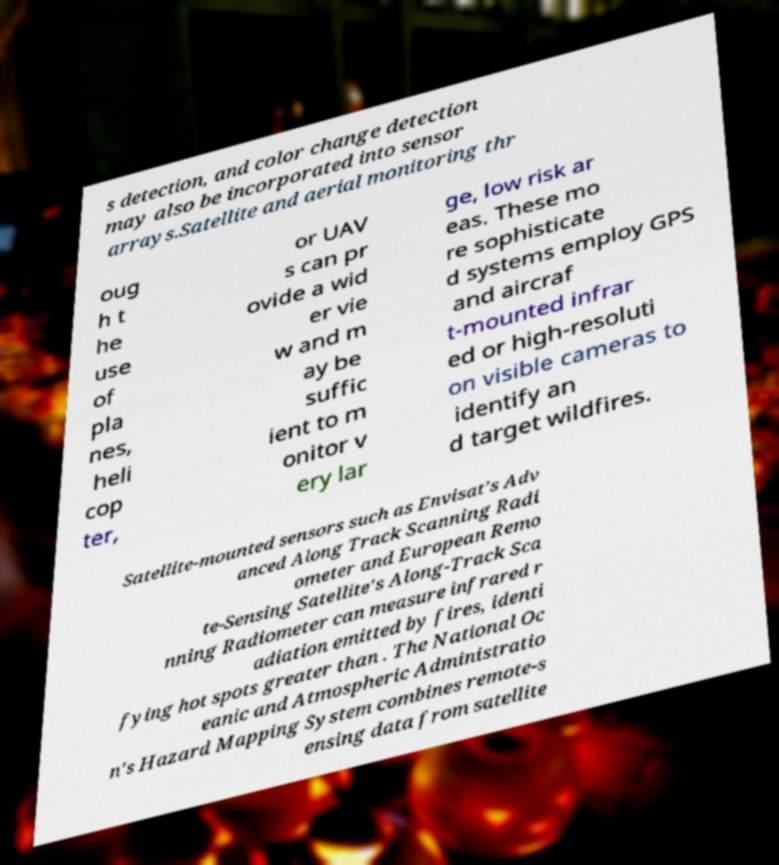Could you extract and type out the text from this image? s detection, and color change detection may also be incorporated into sensor arrays.Satellite and aerial monitoring thr oug h t he use of pla nes, heli cop ter, or UAV s can pr ovide a wid er vie w and m ay be suffic ient to m onitor v ery lar ge, low risk ar eas. These mo re sophisticate d systems employ GPS and aircraf t-mounted infrar ed or high-resoluti on visible cameras to identify an d target wildfires. Satellite-mounted sensors such as Envisat's Adv anced Along Track Scanning Radi ometer and European Remo te-Sensing Satellite's Along-Track Sca nning Radiometer can measure infrared r adiation emitted by fires, identi fying hot spots greater than . The National Oc eanic and Atmospheric Administratio n's Hazard Mapping System combines remote-s ensing data from satellite 